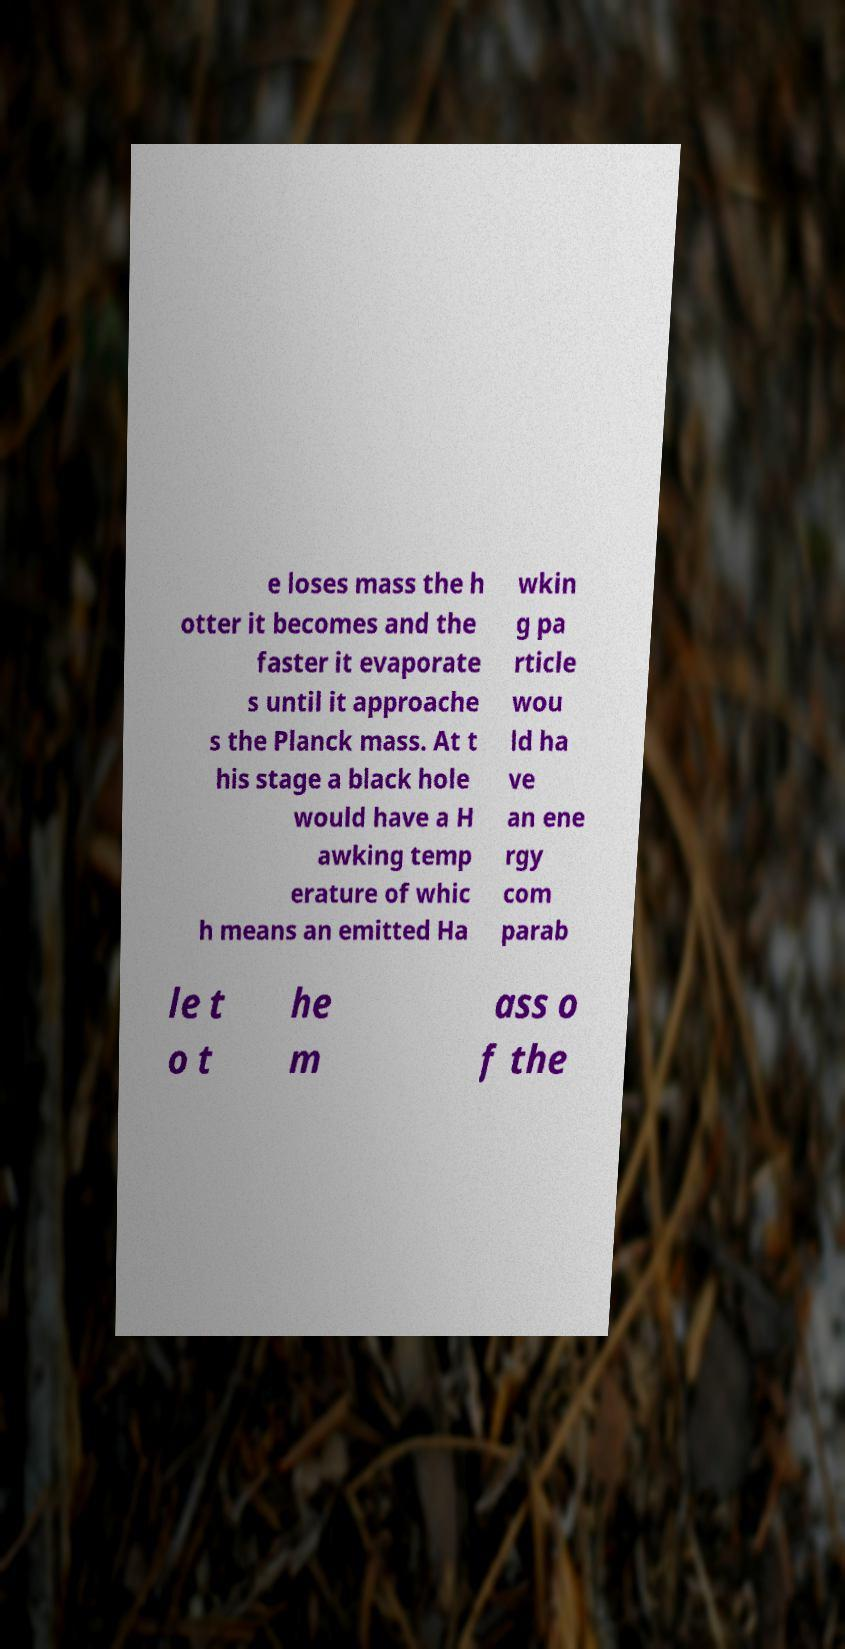I need the written content from this picture converted into text. Can you do that? e loses mass the h otter it becomes and the faster it evaporate s until it approache s the Planck mass. At t his stage a black hole would have a H awking temp erature of whic h means an emitted Ha wkin g pa rticle wou ld ha ve an ene rgy com parab le t o t he m ass o f the 